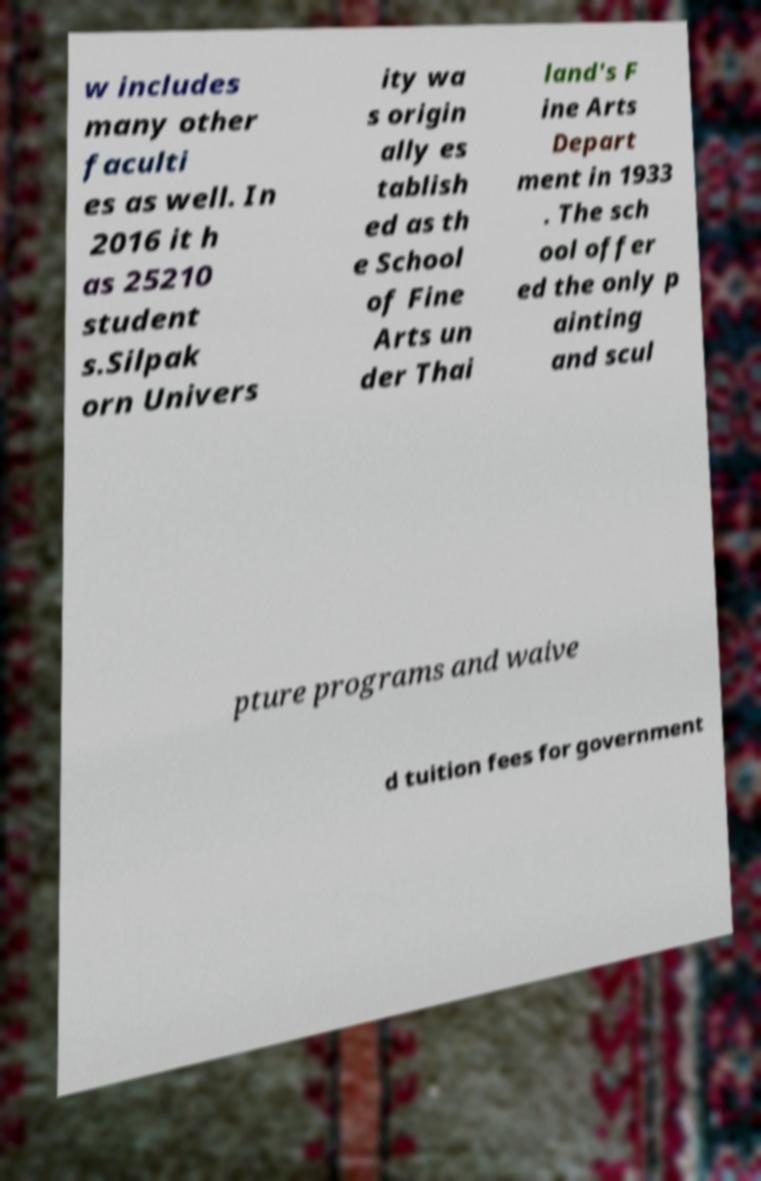Can you read and provide the text displayed in the image?This photo seems to have some interesting text. Can you extract and type it out for me? w includes many other faculti es as well. In 2016 it h as 25210 student s.Silpak orn Univers ity wa s origin ally es tablish ed as th e School of Fine Arts un der Thai land's F ine Arts Depart ment in 1933 . The sch ool offer ed the only p ainting and scul pture programs and waive d tuition fees for government 